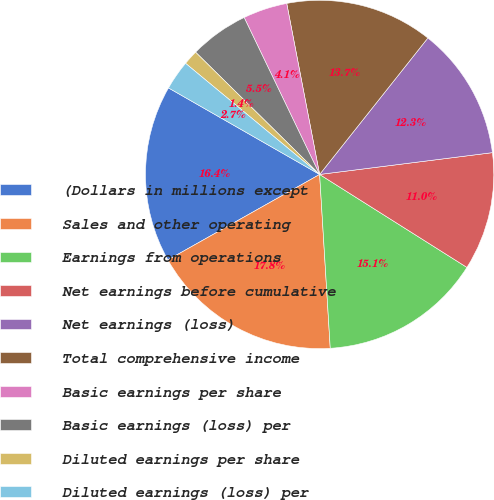<chart> <loc_0><loc_0><loc_500><loc_500><pie_chart><fcel>(Dollars in millions except<fcel>Sales and other operating<fcel>Earnings from operations<fcel>Net earnings before cumulative<fcel>Net earnings (loss)<fcel>Total comprehensive income<fcel>Basic earnings per share<fcel>Basic earnings (loss) per<fcel>Diluted earnings per share<fcel>Diluted earnings (loss) per<nl><fcel>16.44%<fcel>17.81%<fcel>15.07%<fcel>10.96%<fcel>12.33%<fcel>13.7%<fcel>4.11%<fcel>5.48%<fcel>1.37%<fcel>2.74%<nl></chart> 